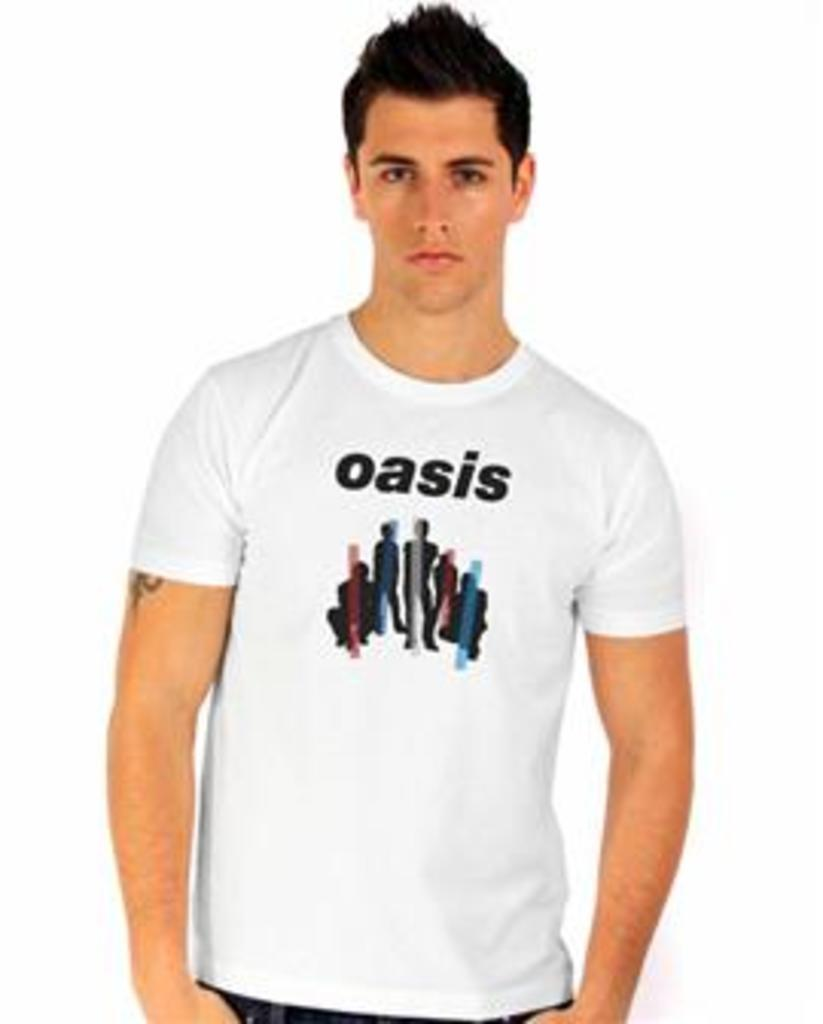What is the main subject of the image? There is a person in the image. What is the person wearing? The person is wearing a white T-shirt. Can you describe the design on the T-shirt? The T-shirt has text and other persons printed on it. What is the color of the background in the image? The background of the image is white. How many times does the person kick a ball in the image? There is no ball or kicking action present in the image. What is the name of the person who was born in the image? There is no birth or person's name mentioned in the image. 